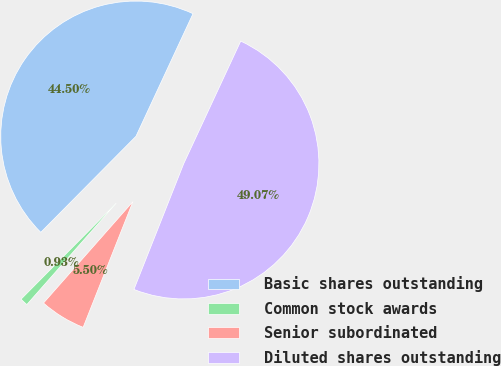Convert chart to OTSL. <chart><loc_0><loc_0><loc_500><loc_500><pie_chart><fcel>Basic shares outstanding<fcel>Common stock awards<fcel>Senior subordinated<fcel>Diluted shares outstanding<nl><fcel>44.5%<fcel>0.93%<fcel>5.5%<fcel>49.07%<nl></chart> 